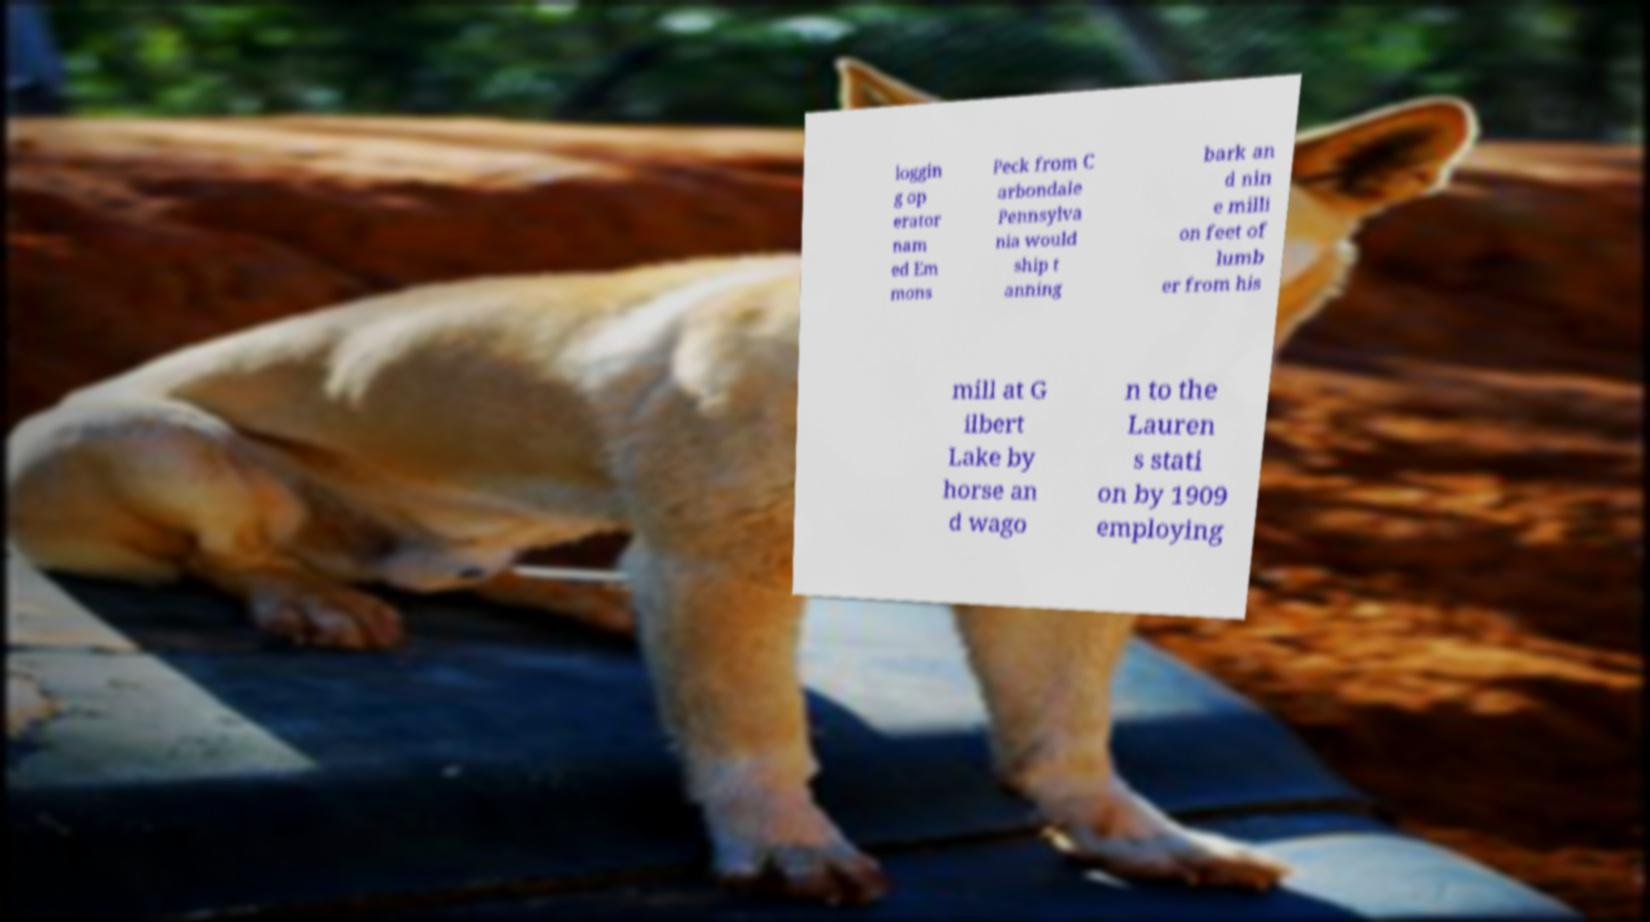Can you read and provide the text displayed in the image?This photo seems to have some interesting text. Can you extract and type it out for me? loggin g op erator nam ed Em mons Peck from C arbondale Pennsylva nia would ship t anning bark an d nin e milli on feet of lumb er from his mill at G ilbert Lake by horse an d wago n to the Lauren s stati on by 1909 employing 